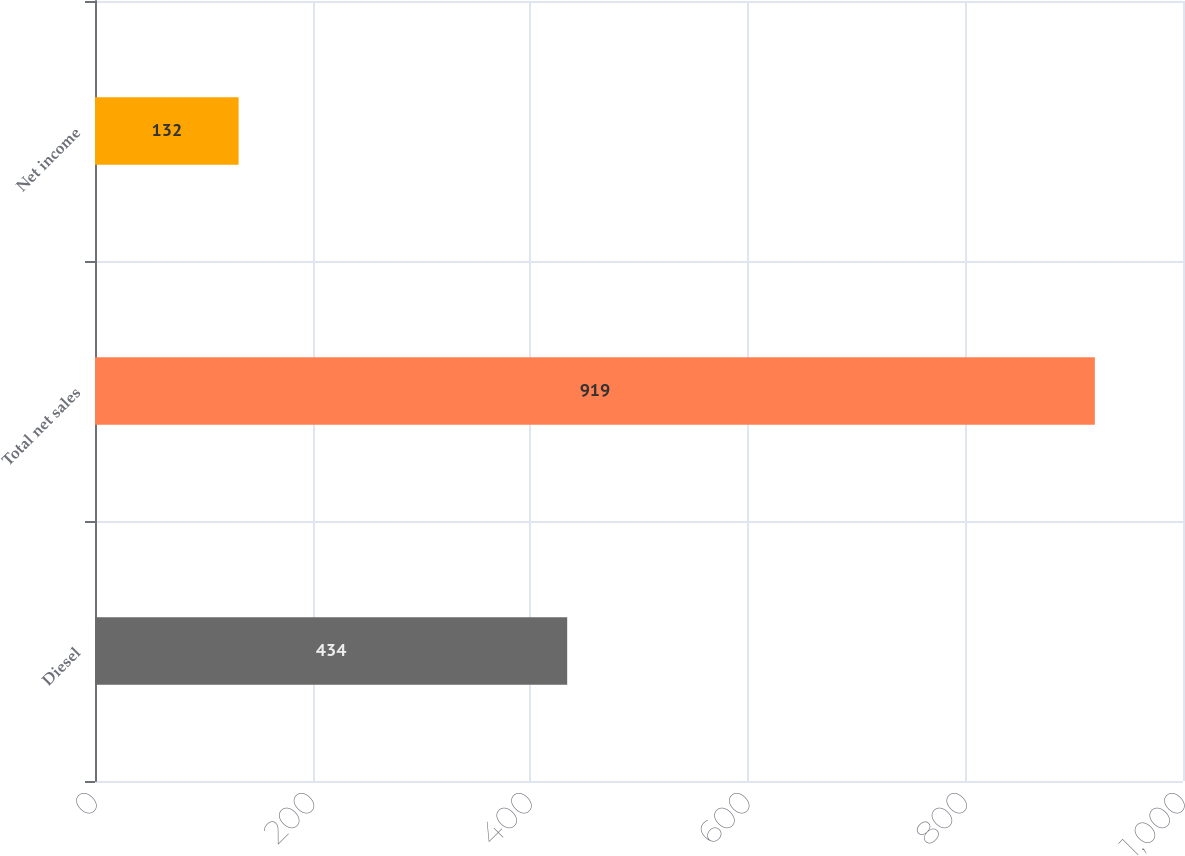Convert chart. <chart><loc_0><loc_0><loc_500><loc_500><bar_chart><fcel>Diesel<fcel>Total net sales<fcel>Net income<nl><fcel>434<fcel>919<fcel>132<nl></chart> 